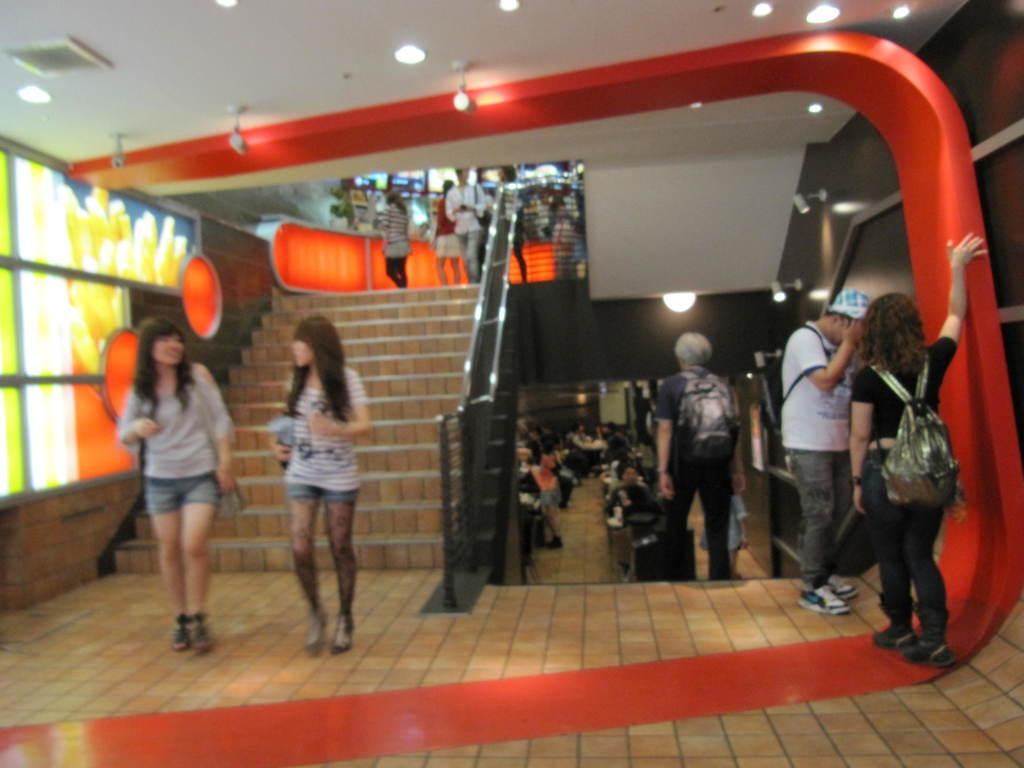What is the main structure visible in the image? There is a class or a similar structure in the image. Who is present near the class? A man is standing near the class. Where are the girls located in the image? There are two girls in the left side of the image. What color are the eyes of the pig in the image? There is no pig present in the image, so it is not possible to determine the color of its eyes. 